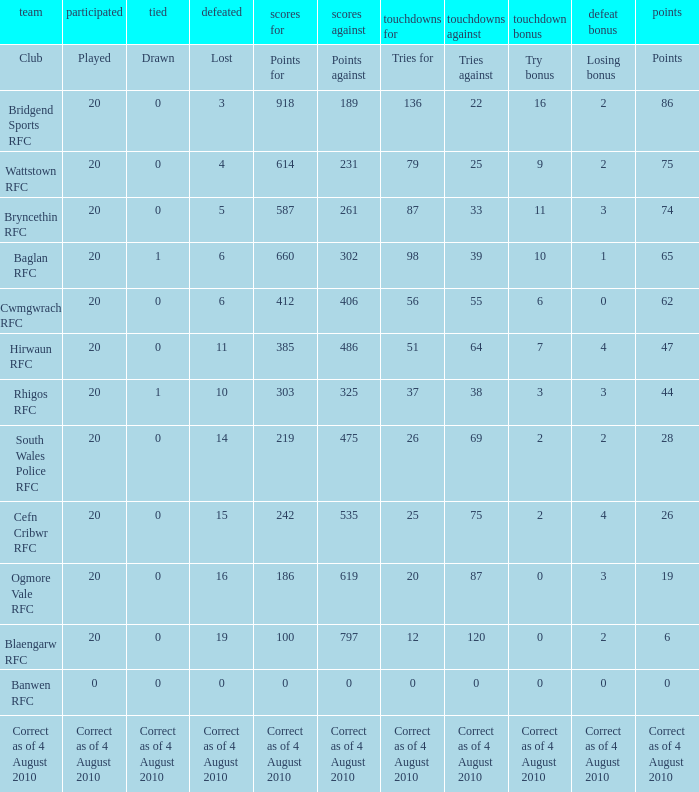What are the counterarguments when a draw is declared? Points against. 